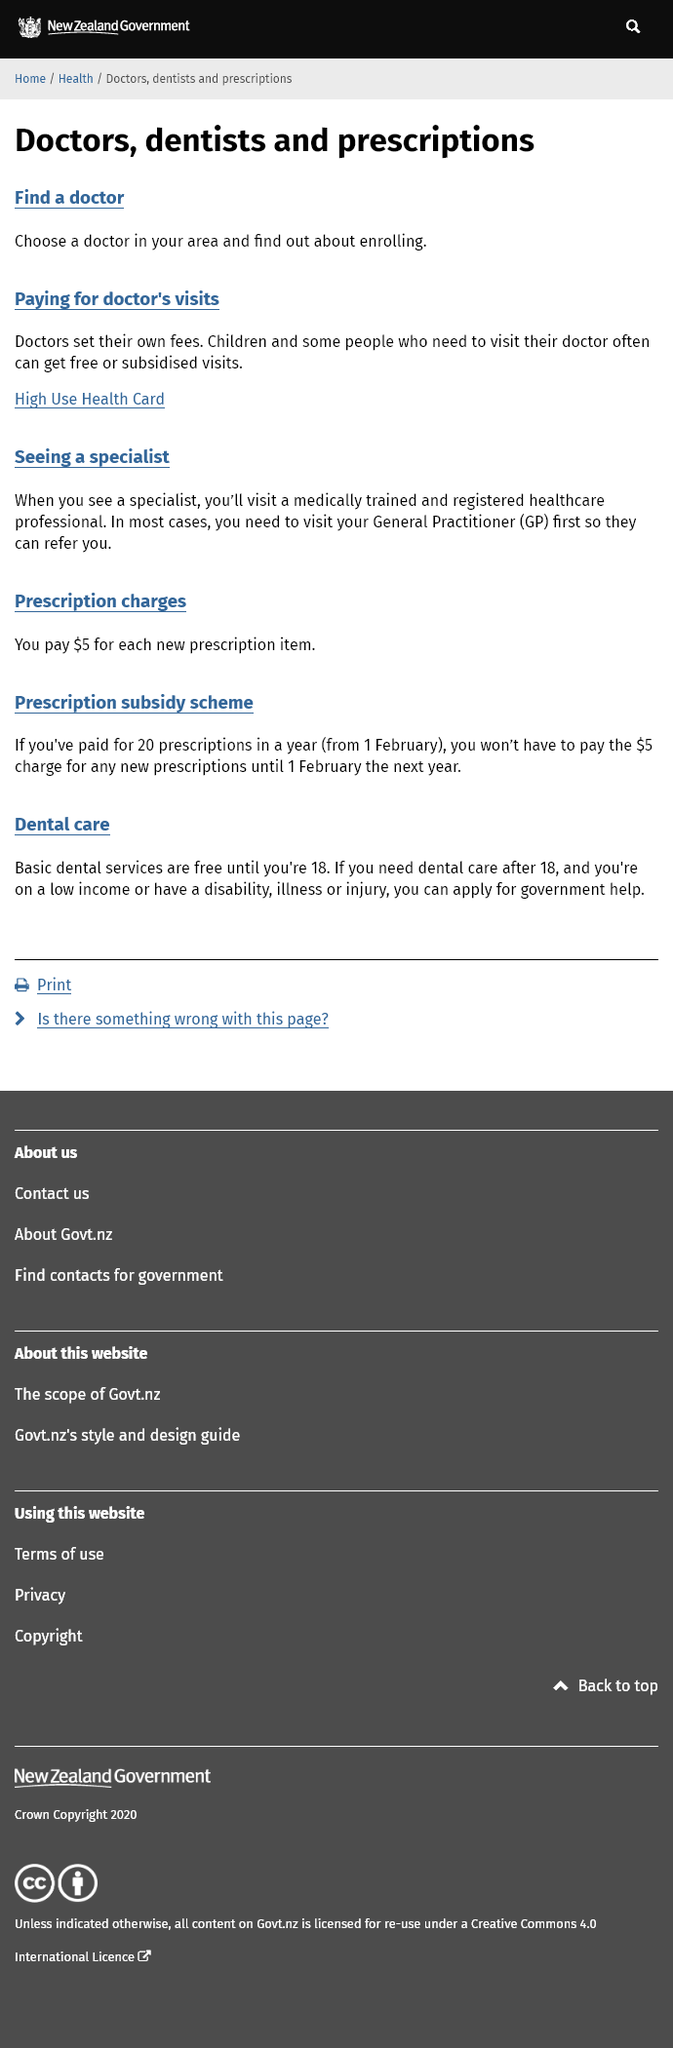Outline some significant characteristics in this image. It is possible to obtain a High Use Health Card if one requires frequent visits to the doctor. It is necessary to visit a General Practitioner (GP) before seeing a specialist in order to receive proper medical care. It is the practice of doctors to set their own fees, rather than being set by external parties, as is the case with many other professions. 